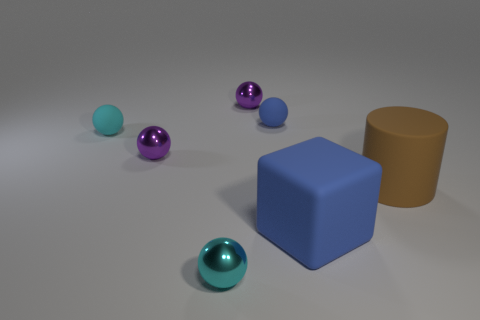The large thing that is in front of the large brown cylinder is what color?
Give a very brief answer. Blue. What is the color of the small rubber thing that is right of the tiny ball in front of the large brown cylinder?
Offer a terse response. Blue. The matte thing that is the same size as the blue sphere is what color?
Your answer should be compact. Cyan. What number of objects are both in front of the large cylinder and on the left side of the tiny blue rubber sphere?
Keep it short and to the point. 1. There is a small thing that is the same color as the big matte block; what is its shape?
Your response must be concise. Sphere. The thing that is both to the left of the big blue rubber thing and in front of the large brown cylinder is made of what material?
Provide a short and direct response. Metal. Is the number of tiny metallic balls in front of the big blue rubber thing less than the number of cyan things that are right of the cyan shiny thing?
Your response must be concise. No. What is the size of the blue cube that is the same material as the brown thing?
Give a very brief answer. Large. Is there any other thing that is the same color as the block?
Your answer should be very brief. Yes. Does the brown cylinder have the same material as the blue thing that is in front of the small blue object?
Provide a succinct answer. Yes. 